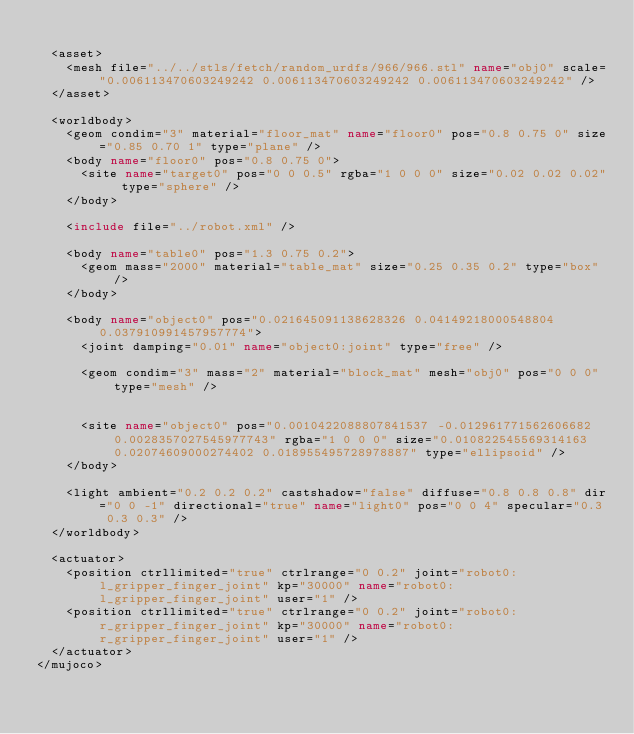Convert code to text. <code><loc_0><loc_0><loc_500><loc_500><_XML_>
	<asset>
		<mesh file="../../stls/fetch/random_urdfs/966/966.stl" name="obj0" scale="0.006113470603249242 0.006113470603249242 0.006113470603249242" />
	</asset>

	<worldbody>
		<geom condim="3" material="floor_mat" name="floor0" pos="0.8 0.75 0" size="0.85 0.70 1" type="plane" />
		<body name="floor0" pos="0.8 0.75 0">
			<site name="target0" pos="0 0 0.5" rgba="1 0 0 0" size="0.02 0.02 0.02" type="sphere" />
		</body>

		<include file="../robot.xml" />

		<body name="table0" pos="1.3 0.75 0.2">
			<geom mass="2000" material="table_mat" size="0.25 0.35 0.2" type="box" />
		</body>

		<body name="object0" pos="0.021645091138628326 0.04149218000548804 0.037910991457957774">
			<joint damping="0.01" name="object0:joint" type="free" />
			
			<geom condim="3" mass="2" material="block_mat" mesh="obj0" pos="0 0 0" type="mesh" />
			
			
			<site name="object0" pos="0.0010422088807841537 -0.012961771562606682 0.0028357027545977743" rgba="1 0 0 0" size="0.010822545569314163 0.02074609000274402 0.018955495728978887" type="ellipsoid" />
		</body>

		<light ambient="0.2 0.2 0.2" castshadow="false" diffuse="0.8 0.8 0.8" dir="0 0 -1" directional="true" name="light0" pos="0 0 4" specular="0.3 0.3 0.3" />
	</worldbody>

	<actuator>
		<position ctrllimited="true" ctrlrange="0 0.2" joint="robot0:l_gripper_finger_joint" kp="30000" name="robot0:l_gripper_finger_joint" user="1" />
		<position ctrllimited="true" ctrlrange="0 0.2" joint="robot0:r_gripper_finger_joint" kp="30000" name="robot0:r_gripper_finger_joint" user="1" />
	</actuator>
</mujoco></code> 